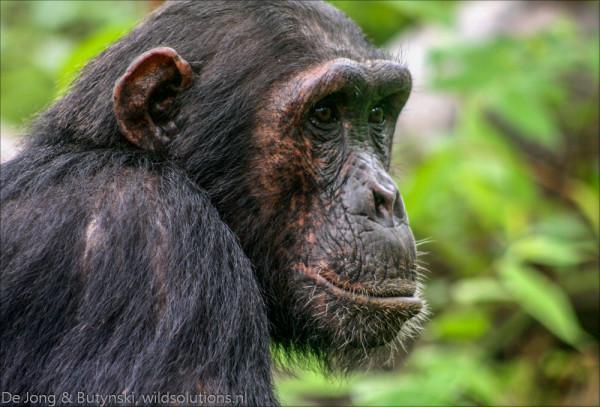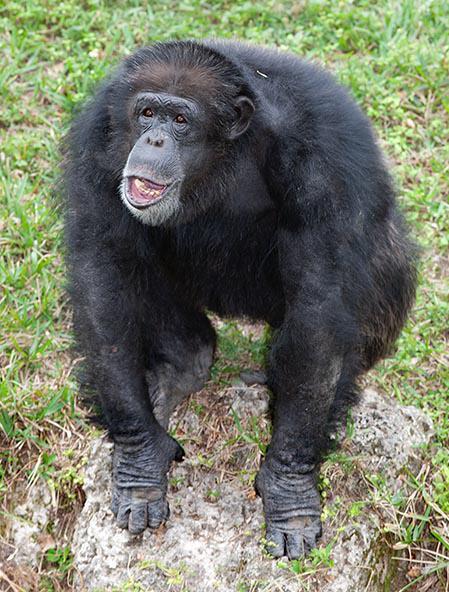The first image is the image on the left, the second image is the image on the right. Evaluate the accuracy of this statement regarding the images: "In one image a chimp is making an O shape with their mouth". Is it true? Answer yes or no. No. 